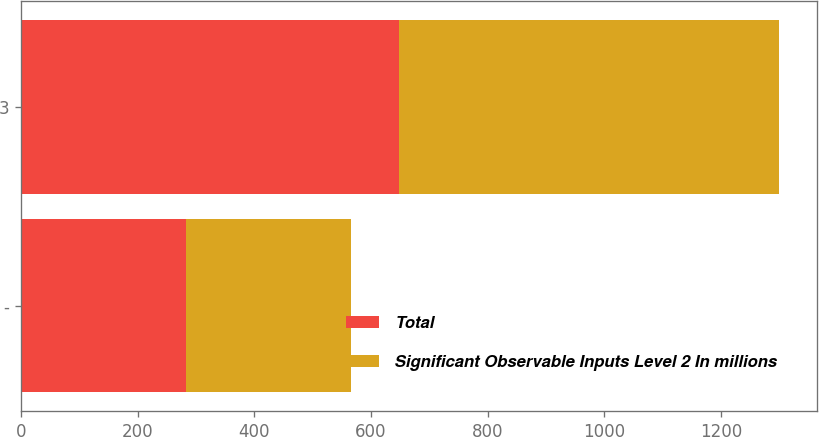Convert chart. <chart><loc_0><loc_0><loc_500><loc_500><stacked_bar_chart><ecel><fcel>-<fcel>3<nl><fcel>Total<fcel>283<fcel>648<nl><fcel>Significant Observable Inputs Level 2 In millions<fcel>283<fcel>651<nl></chart> 